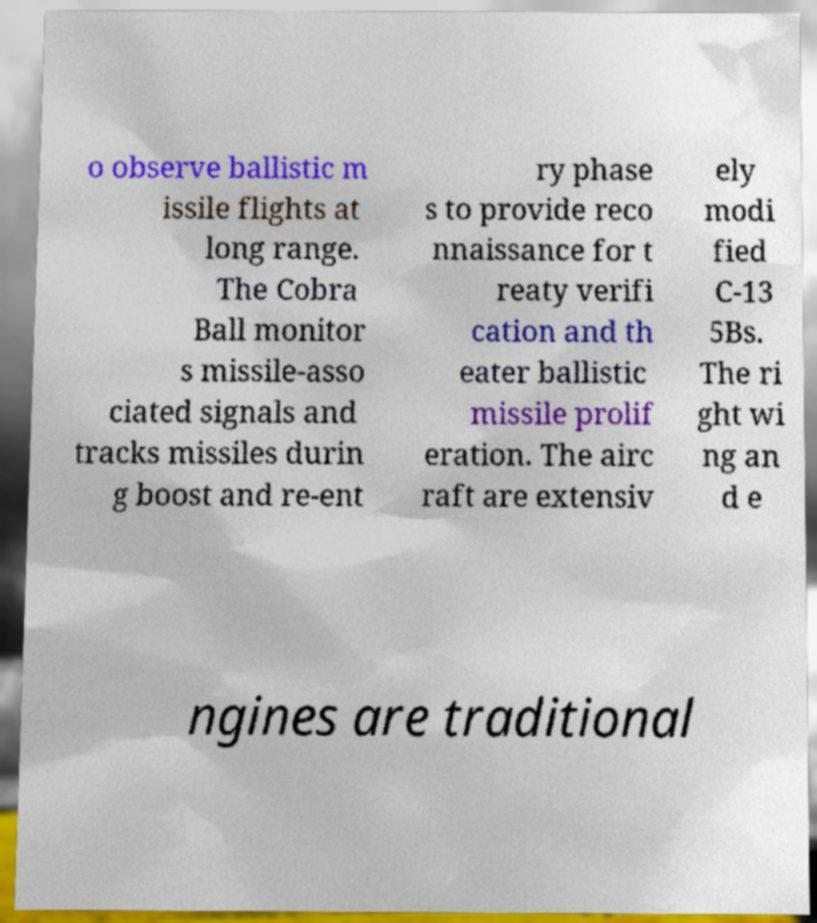Please identify and transcribe the text found in this image. o observe ballistic m issile flights at long range. The Cobra Ball monitor s missile-asso ciated signals and tracks missiles durin g boost and re-ent ry phase s to provide reco nnaissance for t reaty verifi cation and th eater ballistic missile prolif eration. The airc raft are extensiv ely modi fied C-13 5Bs. The ri ght wi ng an d e ngines are traditional 